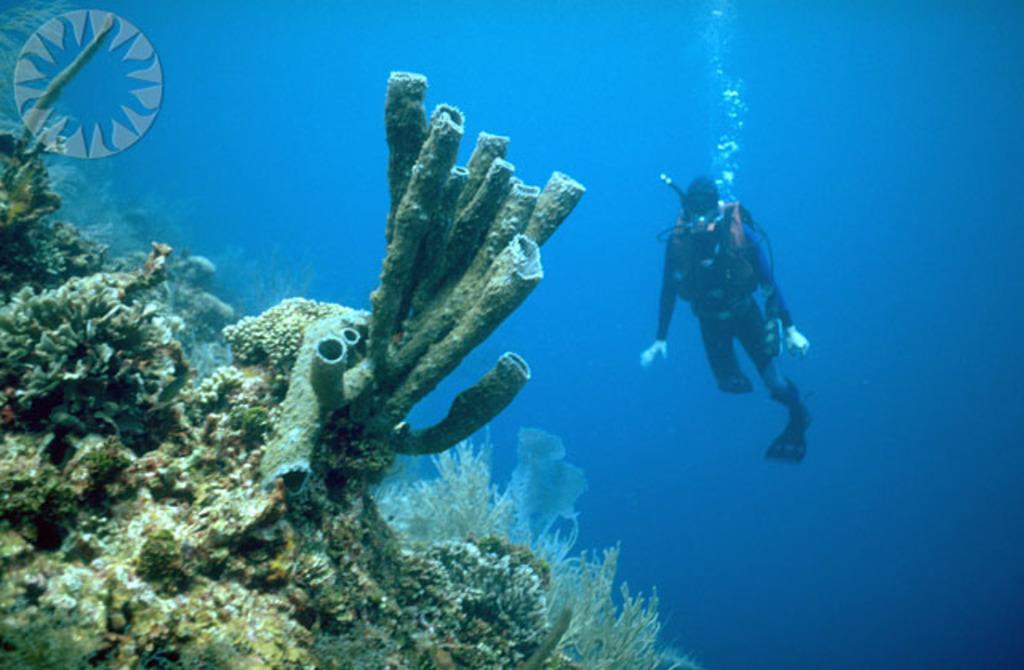How would you summarize this image in a sentence or two? In this image, we can see corals, sea lettuce. Background we can see blue water. Here a person is diving in the water. left side top corner, there is a logo in the image. 